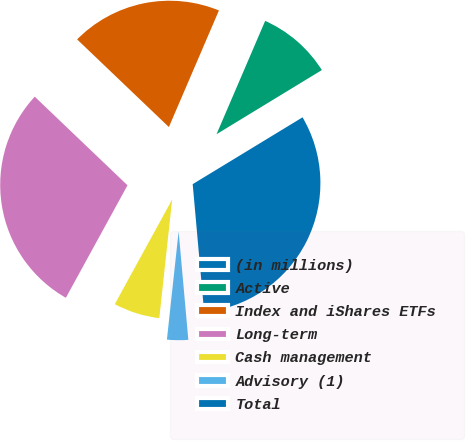<chart> <loc_0><loc_0><loc_500><loc_500><pie_chart><fcel>(in millions)<fcel>Active<fcel>Index and iShares ETFs<fcel>Long-term<fcel>Cash management<fcel>Advisory (1)<fcel>Total<nl><fcel>0.01%<fcel>9.84%<fcel>19.32%<fcel>29.16%<fcel>6.26%<fcel>3.14%<fcel>32.28%<nl></chart> 